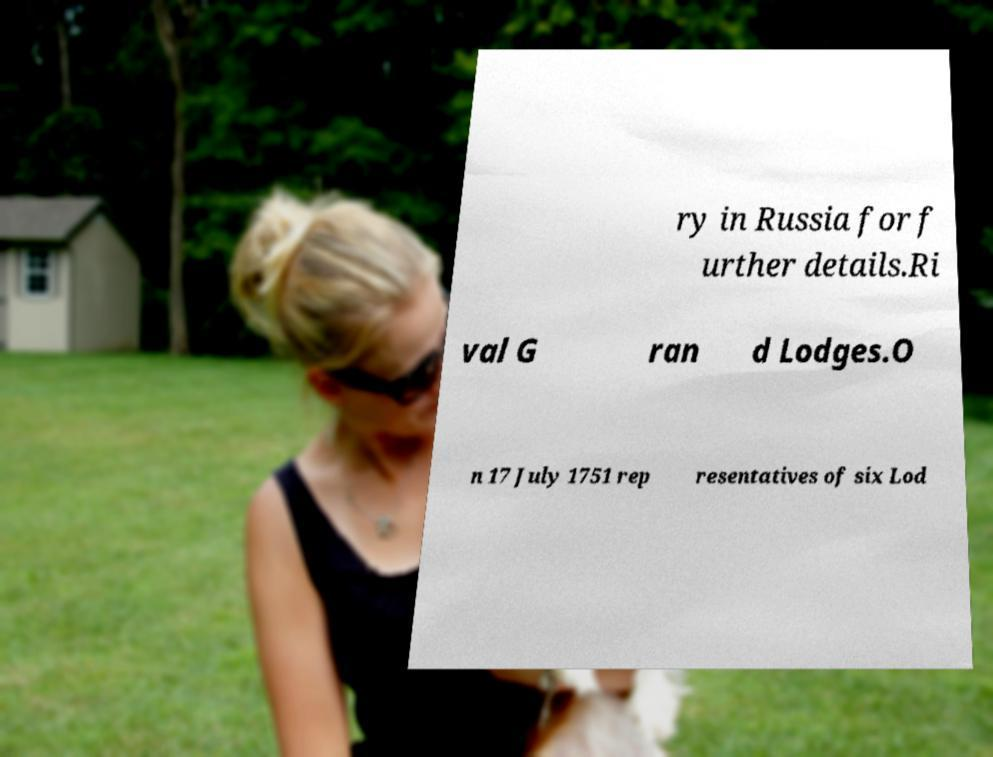Can you read and provide the text displayed in the image?This photo seems to have some interesting text. Can you extract and type it out for me? ry in Russia for f urther details.Ri val G ran d Lodges.O n 17 July 1751 rep resentatives of six Lod 